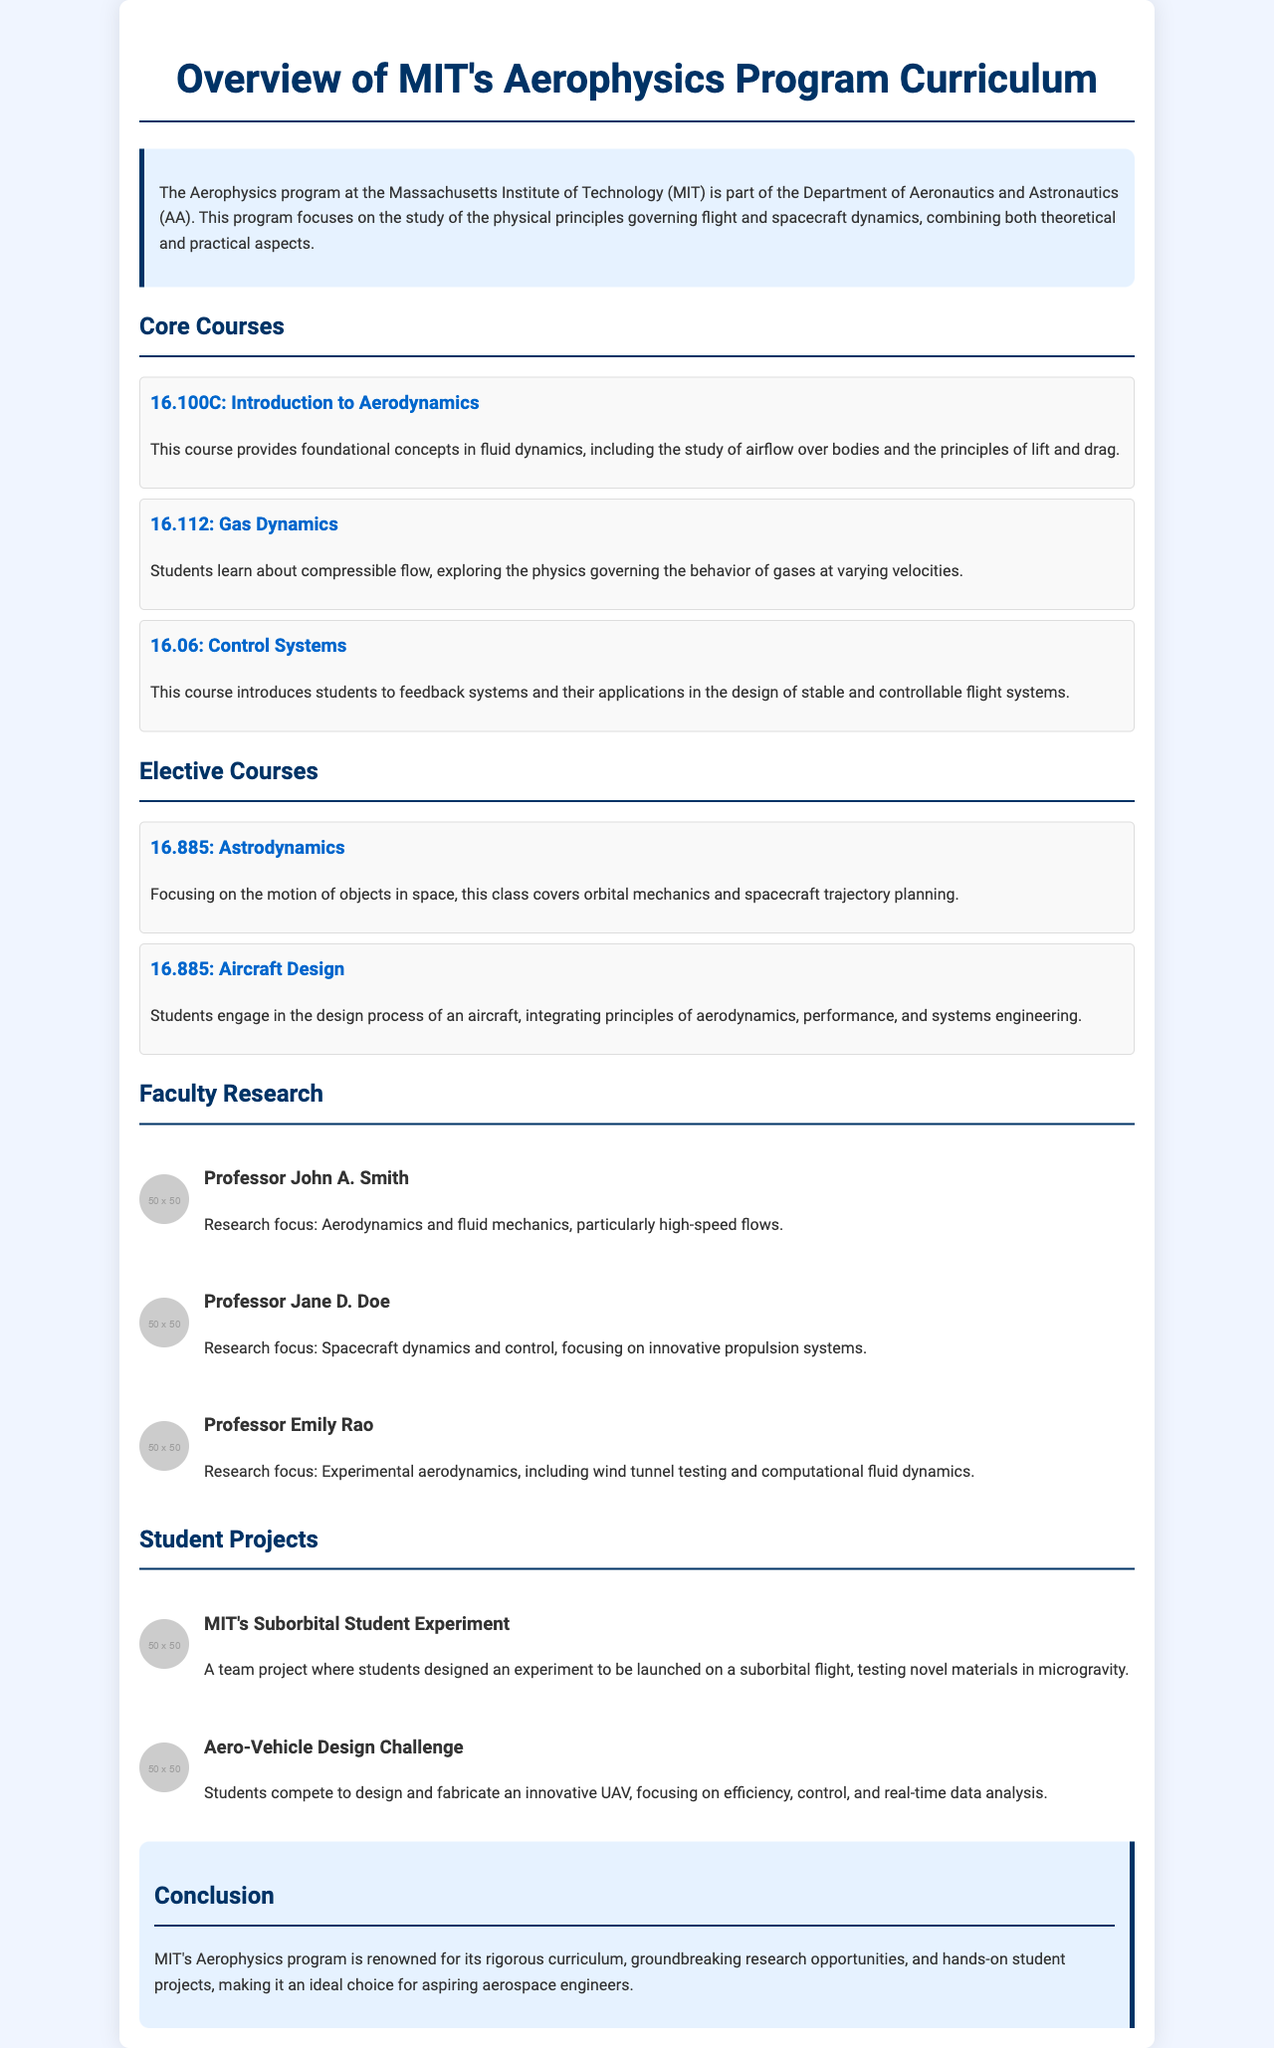what is the name of the program? The program is identified as the Aerophysics program at MIT, which is part of the Department of Aeronautics and Astronautics.
Answer: Aerophysics program how many core courses are listed? The document lists three core courses under the Core Courses section.
Answer: three who is the faculty member focused on high-speed flows? Professor John A. Smith is mentioned as the faculty member whose research focus is on aerodynamics and fluid mechanics, particularly high-speed flows.
Answer: Professor John A. Smith what type of project involves testing novel materials in microgravity? The project is identified as MIT's Suborbital Student Experiment, which involves designing an experiment for suborbital flight to test novel materials.
Answer: MIT's Suborbital Student Experiment which course covers spacecraft trajectory planning? The course focusing on spacecraft trajectory planning is 16.885: Astrodynamics.
Answer: 16.885: Astrodynamics how many elective courses are mentioned in the document? Two elective courses are highlighted: Astrodynamics and Aircraft Design.
Answer: two what is the main focus of Professor Jane D. Doe's research? Her research focus is on spacecraft dynamics and control, emphasizing innovative propulsion systems.
Answer: Spacecraft dynamics and control what is the conclusion about MIT's Aerophysics program? The conclusion emphasizes that the program is renowned for its rigorous curriculum, research opportunities, and hands-on projects, making it ideal for aspiring aerospace engineers.
Answer: renowned for its rigorous curriculum, research opportunities, and hands-on projects which course introduces feedback systems for flight systems? The course that covers feedback systems in the context of flight systems is 16.06: Control Systems.
Answer: 16.06: Control Systems 